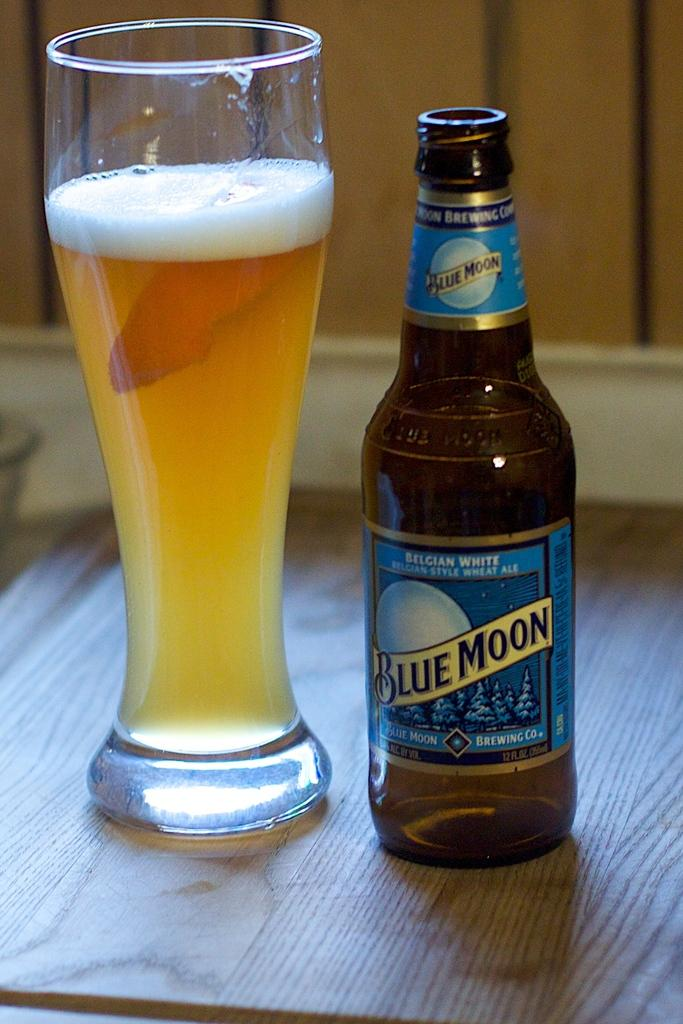What type of container is in the image? There is a glass bottle in the image. What is written on the glass bottle? The glass bottle has the name "blue moon" on it. What other glass object is on the table in the image? There is a glass on the table in the image. Where are the glass bottle and glass located in the image? The glass bottle and glass are on a table. What color is the gold control panel on the table in the image? There is no gold control panel present in the image; it only features a glass bottle, a glass, and a table. 